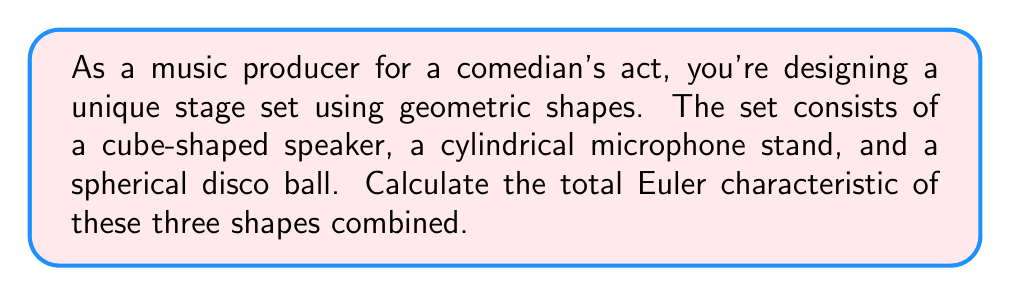Show me your answer to this math problem. To solve this problem, we need to calculate the Euler characteristic for each shape and then sum them up. The Euler characteristic ($\chi$) is defined as:

$$\chi = V - E + F$$

Where:
$V$ = number of vertices
$E$ = number of edges
$F$ = number of faces

Let's break it down for each shape:

1. Cube (speaker):
   - Vertices: 8
   - Edges: 12
   - Faces: 6
   $$\chi_{cube} = 8 - 12 + 6 = 2$$

2. Cylinder (microphone stand):
   - Vertices: 0 (curved surface has no vertices)
   - Edges: 2 (top and bottom circular edges)
   - Faces: 3 (top, bottom, and curved surface)
   $$\chi_{cylinder} = 0 - 2 + 3 = 1$$

3. Sphere (disco ball):
   - Vertices: 0
   - Edges: 0
   - Faces: 1 (the entire surface is one face)
   $$\chi_{sphere} = 0 - 0 + 1 = 1$$

To find the total Euler characteristic, we sum the individual characteristics:

$$\chi_{total} = \chi_{cube} + \chi_{cylinder} + \chi_{sphere}$$
$$\chi_{total} = 2 + 1 + 1 = 4$$
Answer: $4$ 